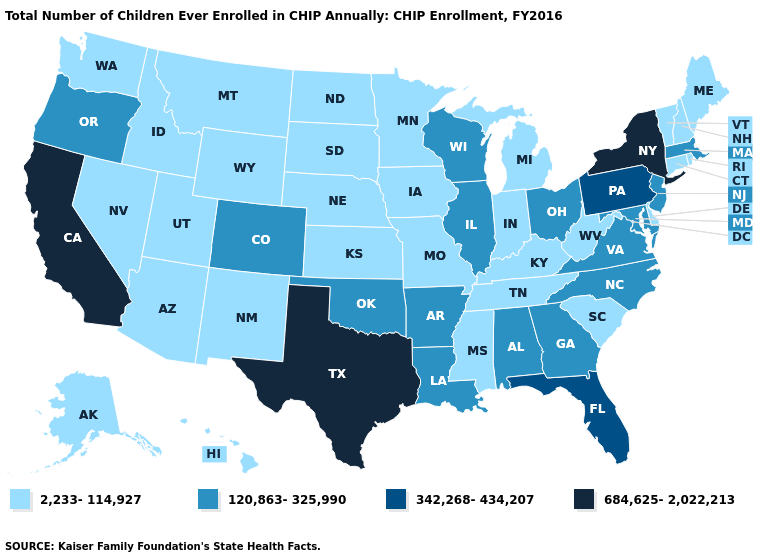Among the states that border Oregon , which have the lowest value?
Give a very brief answer. Idaho, Nevada, Washington. Does Idaho have the same value as Tennessee?
Write a very short answer. Yes. Name the states that have a value in the range 342,268-434,207?
Keep it brief. Florida, Pennsylvania. Does Oregon have the same value as Nebraska?
Keep it brief. No. Does New York have the highest value in the Northeast?
Short answer required. Yes. What is the value of Oklahoma?
Short answer required. 120,863-325,990. Does New York have the highest value in the Northeast?
Be succinct. Yes. What is the value of New Hampshire?
Give a very brief answer. 2,233-114,927. What is the value of Maine?
Give a very brief answer. 2,233-114,927. Which states have the lowest value in the USA?
Short answer required. Alaska, Arizona, Connecticut, Delaware, Hawaii, Idaho, Indiana, Iowa, Kansas, Kentucky, Maine, Michigan, Minnesota, Mississippi, Missouri, Montana, Nebraska, Nevada, New Hampshire, New Mexico, North Dakota, Rhode Island, South Carolina, South Dakota, Tennessee, Utah, Vermont, Washington, West Virginia, Wyoming. Name the states that have a value in the range 120,863-325,990?
Concise answer only. Alabama, Arkansas, Colorado, Georgia, Illinois, Louisiana, Maryland, Massachusetts, New Jersey, North Carolina, Ohio, Oklahoma, Oregon, Virginia, Wisconsin. Name the states that have a value in the range 2,233-114,927?
Quick response, please. Alaska, Arizona, Connecticut, Delaware, Hawaii, Idaho, Indiana, Iowa, Kansas, Kentucky, Maine, Michigan, Minnesota, Mississippi, Missouri, Montana, Nebraska, Nevada, New Hampshire, New Mexico, North Dakota, Rhode Island, South Carolina, South Dakota, Tennessee, Utah, Vermont, Washington, West Virginia, Wyoming. Is the legend a continuous bar?
Keep it brief. No. Name the states that have a value in the range 342,268-434,207?
Give a very brief answer. Florida, Pennsylvania. Which states have the lowest value in the USA?
Write a very short answer. Alaska, Arizona, Connecticut, Delaware, Hawaii, Idaho, Indiana, Iowa, Kansas, Kentucky, Maine, Michigan, Minnesota, Mississippi, Missouri, Montana, Nebraska, Nevada, New Hampshire, New Mexico, North Dakota, Rhode Island, South Carolina, South Dakota, Tennessee, Utah, Vermont, Washington, West Virginia, Wyoming. 